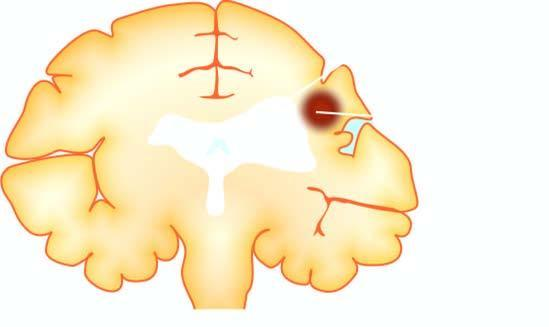s the periphery shrinkage of scarred area with ipsilateral ventricular dilatation?
Answer the question using a single word or phrase. No 